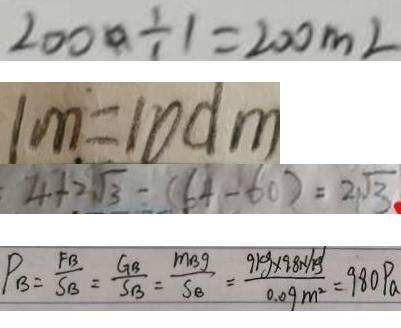<formula> <loc_0><loc_0><loc_500><loc_500>2 0 0 0 \div 1 = 2 0 0 m l 
 1 m = 1 0 d m 
 4 + 2 \sqrt { 3 } - ( 6 4 - 6 0 ) = 2 \sqrt { 3 } 
 P _ { B } = \frac { F B } { S B } = \frac { G _ { B } } { S _ { B } } = \frac { m _ { B g } } { S _ { B } } = \frac { 9 k g \times 9 . 8 . N / g } { 0 . 0 9 m ^ { 2 } } = 9 8 0 P a</formula> 